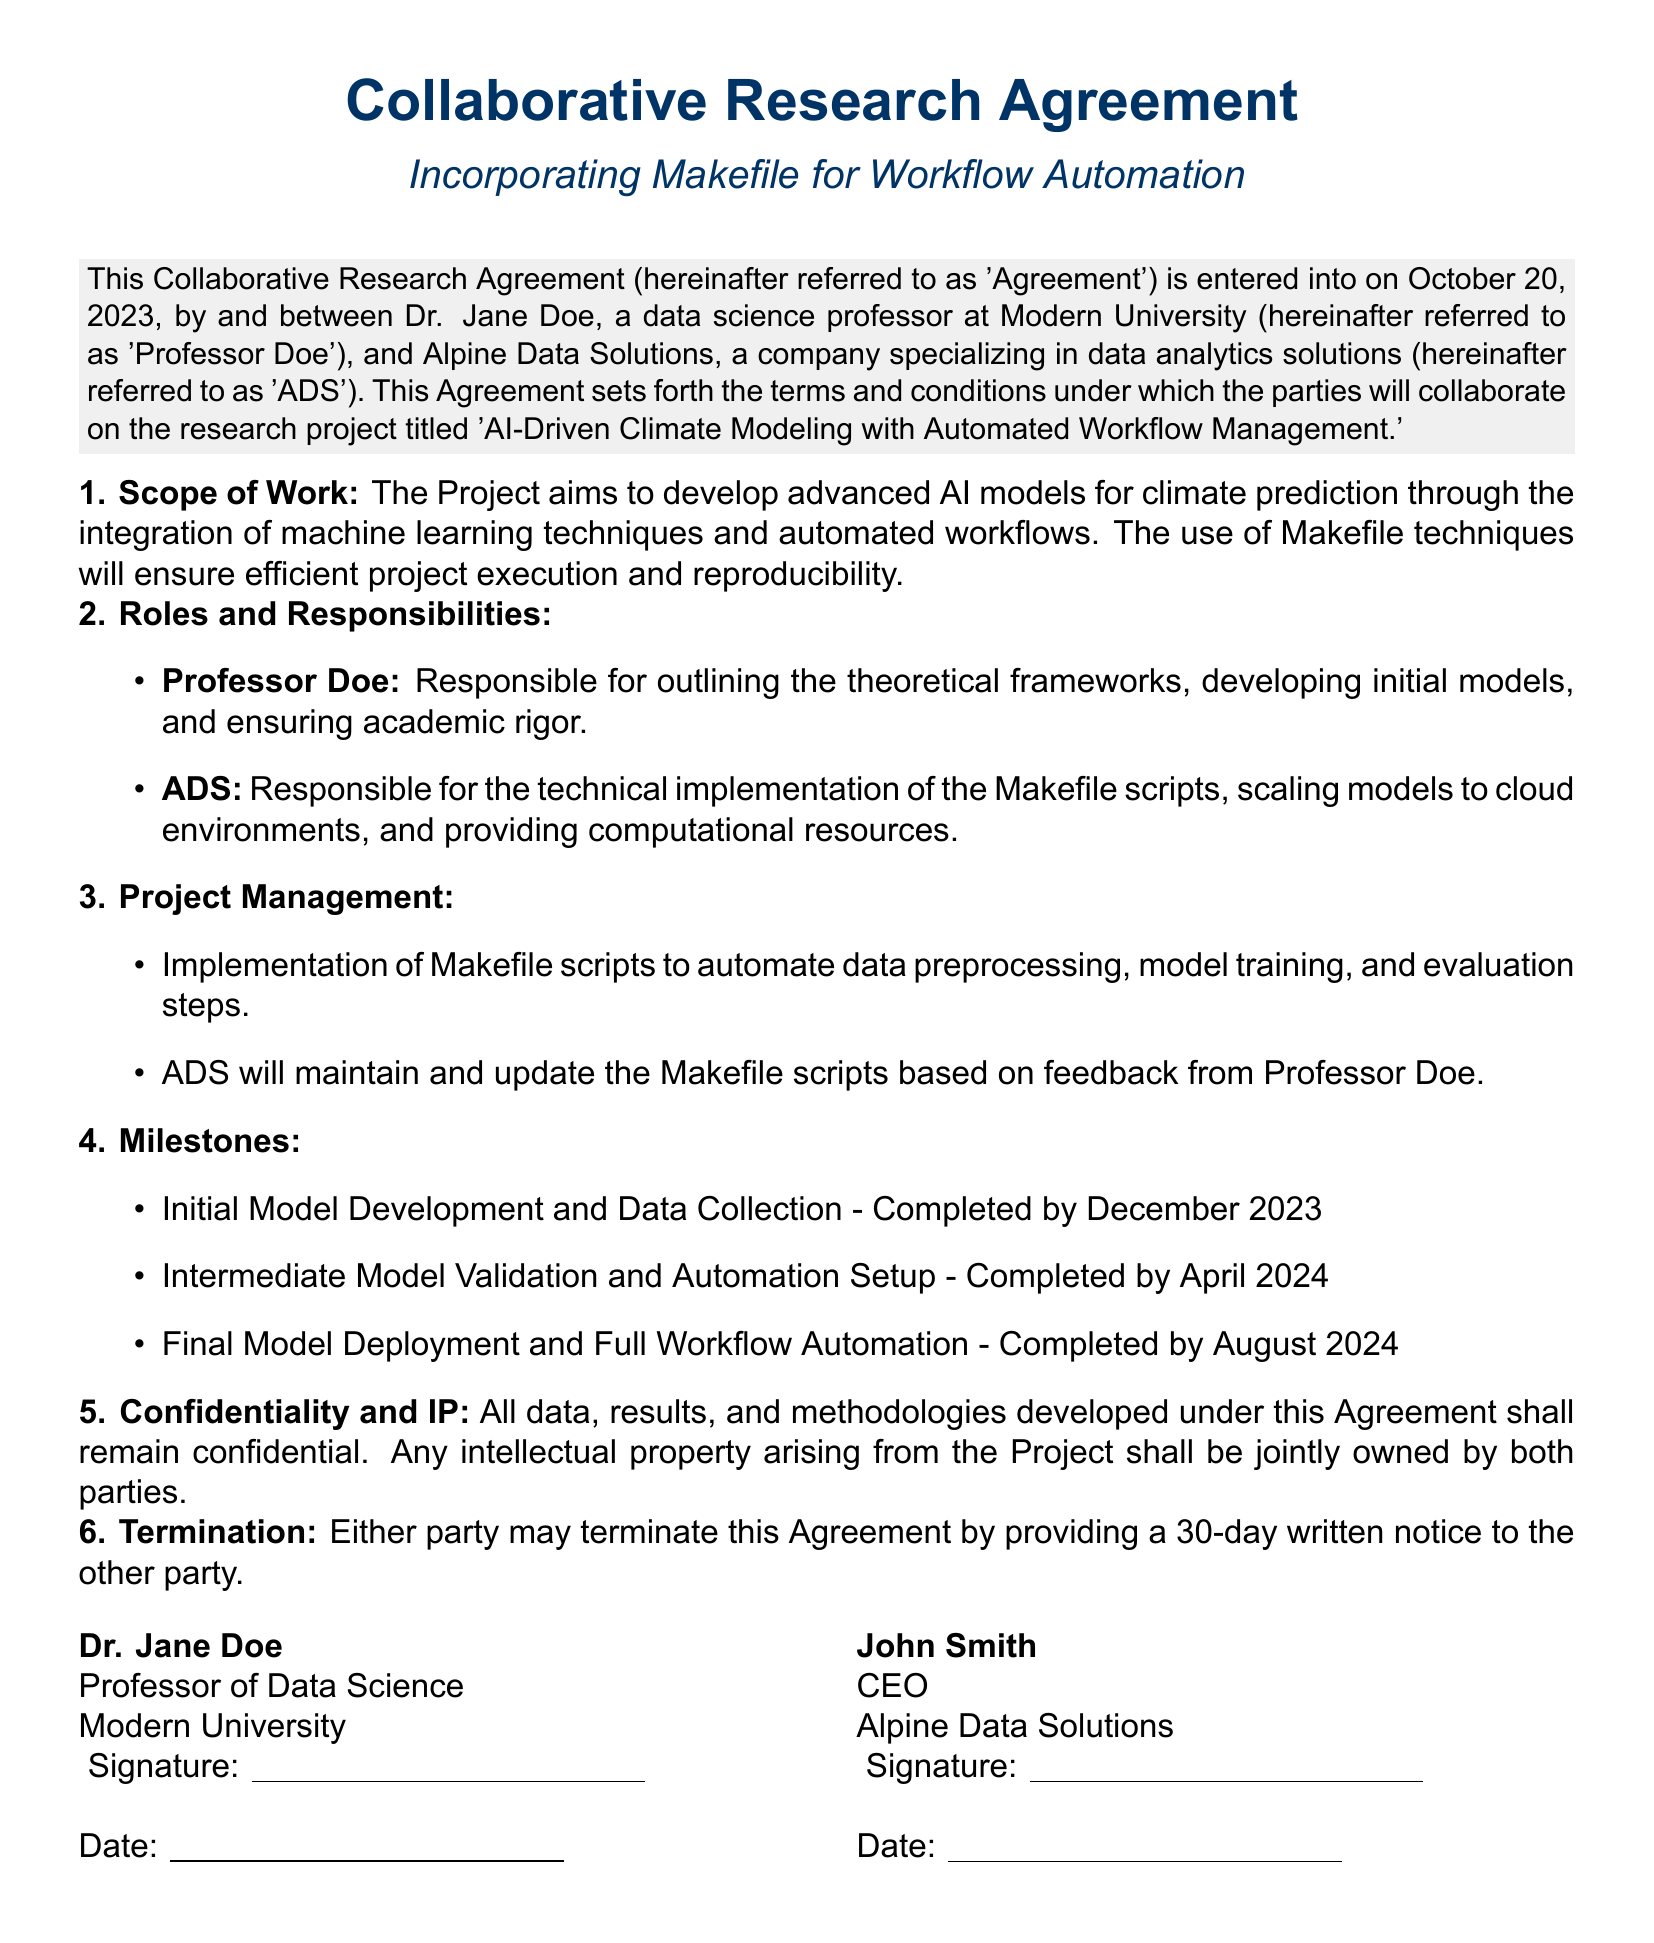what is the date the Agreement was entered into? The date the Agreement was entered into is specified in the introductory paragraph of the document.
Answer: October 20, 2023 who is referred to as 'ADS'? 'ADS' is defined in the introductory paragraph as the entity participating in the Agreement.
Answer: Alpine Data Solutions what is the title of the research project? The title of the research project is mentioned in the introduction of the Agreement.
Answer: AI-Driven Climate Modeling with Automated Workflow Management what is one responsibility of Professor Doe? The roles and responsibilities of each party are listed in the document, highlighting specific tasks.
Answer: Outlining theoretical frameworks when is the milestone for Final Model Deployment scheduled for completion? The completion date for each milestone is stated in the Milestones section of the document.
Answer: August 2024 who will maintain and update the Makefile scripts? The document specifies the responsibilities of ADS regarding the Makefile scripts under Project Management.
Answer: ADS what is the stipulated notice period for termination of the Agreement? The notice period for termination is clearly stated in the Termination section of the document.
Answer: 30 days what will happen to the intellectual property arising from the Project? The treatment of intellectual property is outlined in the Confidentiality and IP section of the Agreement.
Answer: Jointly owned by both parties what color is used for the title text? The color of the title text is specified in the document concerning its aesthetic design.
Answer: dark blue 